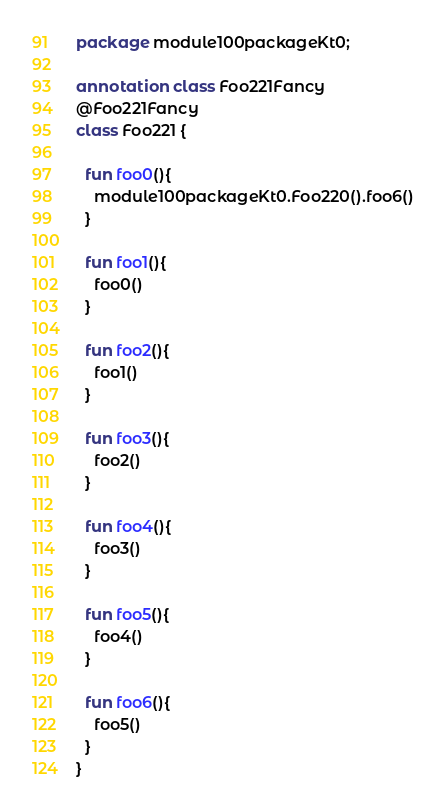Convert code to text. <code><loc_0><loc_0><loc_500><loc_500><_Kotlin_>package module100packageKt0;

annotation class Foo221Fancy
@Foo221Fancy
class Foo221 {

  fun foo0(){
    module100packageKt0.Foo220().foo6()
  }

  fun foo1(){
    foo0()
  }

  fun foo2(){
    foo1()
  }

  fun foo3(){
    foo2()
  }

  fun foo4(){
    foo3()
  }

  fun foo5(){
    foo4()
  }

  fun foo6(){
    foo5()
  }
}</code> 